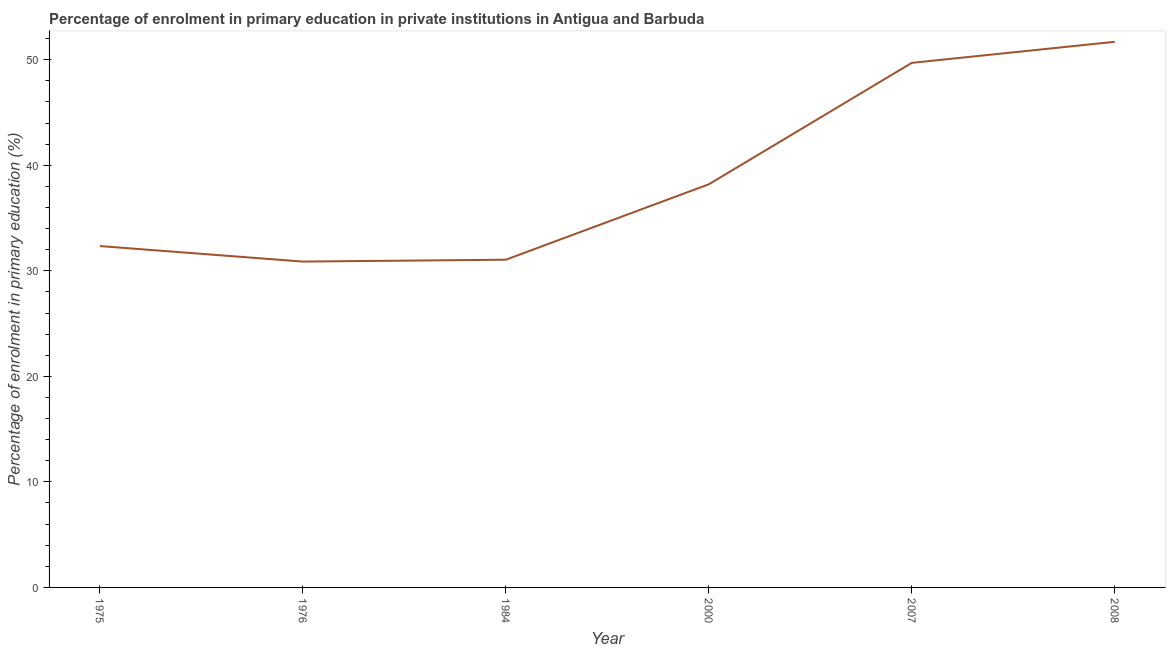What is the enrolment percentage in primary education in 2000?
Your answer should be compact. 38.2. Across all years, what is the maximum enrolment percentage in primary education?
Your response must be concise. 51.7. Across all years, what is the minimum enrolment percentage in primary education?
Make the answer very short. 30.87. In which year was the enrolment percentage in primary education minimum?
Offer a terse response. 1976. What is the sum of the enrolment percentage in primary education?
Offer a terse response. 233.86. What is the difference between the enrolment percentage in primary education in 1984 and 2008?
Offer a very short reply. -20.64. What is the average enrolment percentage in primary education per year?
Your answer should be compact. 38.98. What is the median enrolment percentage in primary education?
Provide a short and direct response. 35.27. What is the ratio of the enrolment percentage in primary education in 1976 to that in 2000?
Ensure brevity in your answer.  0.81. What is the difference between the highest and the second highest enrolment percentage in primary education?
Offer a terse response. 1.99. What is the difference between the highest and the lowest enrolment percentage in primary education?
Provide a succinct answer. 20.82. In how many years, is the enrolment percentage in primary education greater than the average enrolment percentage in primary education taken over all years?
Your answer should be very brief. 2. Does the enrolment percentage in primary education monotonically increase over the years?
Your response must be concise. No. How many years are there in the graph?
Keep it short and to the point. 6. What is the difference between two consecutive major ticks on the Y-axis?
Provide a short and direct response. 10. Does the graph contain any zero values?
Your response must be concise. No. What is the title of the graph?
Keep it short and to the point. Percentage of enrolment in primary education in private institutions in Antigua and Barbuda. What is the label or title of the Y-axis?
Your response must be concise. Percentage of enrolment in primary education (%). What is the Percentage of enrolment in primary education (%) in 1975?
Your response must be concise. 32.34. What is the Percentage of enrolment in primary education (%) of 1976?
Offer a very short reply. 30.87. What is the Percentage of enrolment in primary education (%) in 1984?
Your answer should be compact. 31.05. What is the Percentage of enrolment in primary education (%) in 2000?
Your answer should be very brief. 38.2. What is the Percentage of enrolment in primary education (%) in 2007?
Ensure brevity in your answer.  49.7. What is the Percentage of enrolment in primary education (%) of 2008?
Offer a very short reply. 51.7. What is the difference between the Percentage of enrolment in primary education (%) in 1975 and 1976?
Your answer should be compact. 1.47. What is the difference between the Percentage of enrolment in primary education (%) in 1975 and 1984?
Provide a succinct answer. 1.29. What is the difference between the Percentage of enrolment in primary education (%) in 1975 and 2000?
Give a very brief answer. -5.85. What is the difference between the Percentage of enrolment in primary education (%) in 1975 and 2007?
Make the answer very short. -17.36. What is the difference between the Percentage of enrolment in primary education (%) in 1975 and 2008?
Make the answer very short. -19.35. What is the difference between the Percentage of enrolment in primary education (%) in 1976 and 1984?
Give a very brief answer. -0.18. What is the difference between the Percentage of enrolment in primary education (%) in 1976 and 2000?
Your answer should be compact. -7.32. What is the difference between the Percentage of enrolment in primary education (%) in 1976 and 2007?
Your answer should be very brief. -18.83. What is the difference between the Percentage of enrolment in primary education (%) in 1976 and 2008?
Give a very brief answer. -20.82. What is the difference between the Percentage of enrolment in primary education (%) in 1984 and 2000?
Provide a succinct answer. -7.14. What is the difference between the Percentage of enrolment in primary education (%) in 1984 and 2007?
Ensure brevity in your answer.  -18.65. What is the difference between the Percentage of enrolment in primary education (%) in 1984 and 2008?
Ensure brevity in your answer.  -20.64. What is the difference between the Percentage of enrolment in primary education (%) in 2000 and 2007?
Your answer should be compact. -11.51. What is the difference between the Percentage of enrolment in primary education (%) in 2000 and 2008?
Your response must be concise. -13.5. What is the difference between the Percentage of enrolment in primary education (%) in 2007 and 2008?
Give a very brief answer. -1.99. What is the ratio of the Percentage of enrolment in primary education (%) in 1975 to that in 1976?
Offer a terse response. 1.05. What is the ratio of the Percentage of enrolment in primary education (%) in 1975 to that in 1984?
Give a very brief answer. 1.04. What is the ratio of the Percentage of enrolment in primary education (%) in 1975 to that in 2000?
Your answer should be compact. 0.85. What is the ratio of the Percentage of enrolment in primary education (%) in 1975 to that in 2007?
Ensure brevity in your answer.  0.65. What is the ratio of the Percentage of enrolment in primary education (%) in 1975 to that in 2008?
Make the answer very short. 0.63. What is the ratio of the Percentage of enrolment in primary education (%) in 1976 to that in 2000?
Provide a succinct answer. 0.81. What is the ratio of the Percentage of enrolment in primary education (%) in 1976 to that in 2007?
Your answer should be very brief. 0.62. What is the ratio of the Percentage of enrolment in primary education (%) in 1976 to that in 2008?
Offer a very short reply. 0.6. What is the ratio of the Percentage of enrolment in primary education (%) in 1984 to that in 2000?
Offer a very short reply. 0.81. What is the ratio of the Percentage of enrolment in primary education (%) in 1984 to that in 2007?
Your answer should be very brief. 0.62. What is the ratio of the Percentage of enrolment in primary education (%) in 1984 to that in 2008?
Your response must be concise. 0.6. What is the ratio of the Percentage of enrolment in primary education (%) in 2000 to that in 2007?
Your answer should be very brief. 0.77. What is the ratio of the Percentage of enrolment in primary education (%) in 2000 to that in 2008?
Provide a short and direct response. 0.74. 